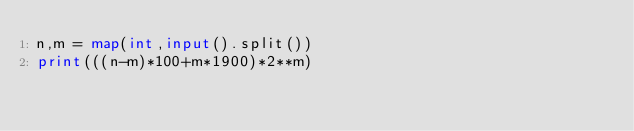<code> <loc_0><loc_0><loc_500><loc_500><_Python_>n,m = map(int,input().split())
print(((n-m)*100+m*1900)*2**m)</code> 